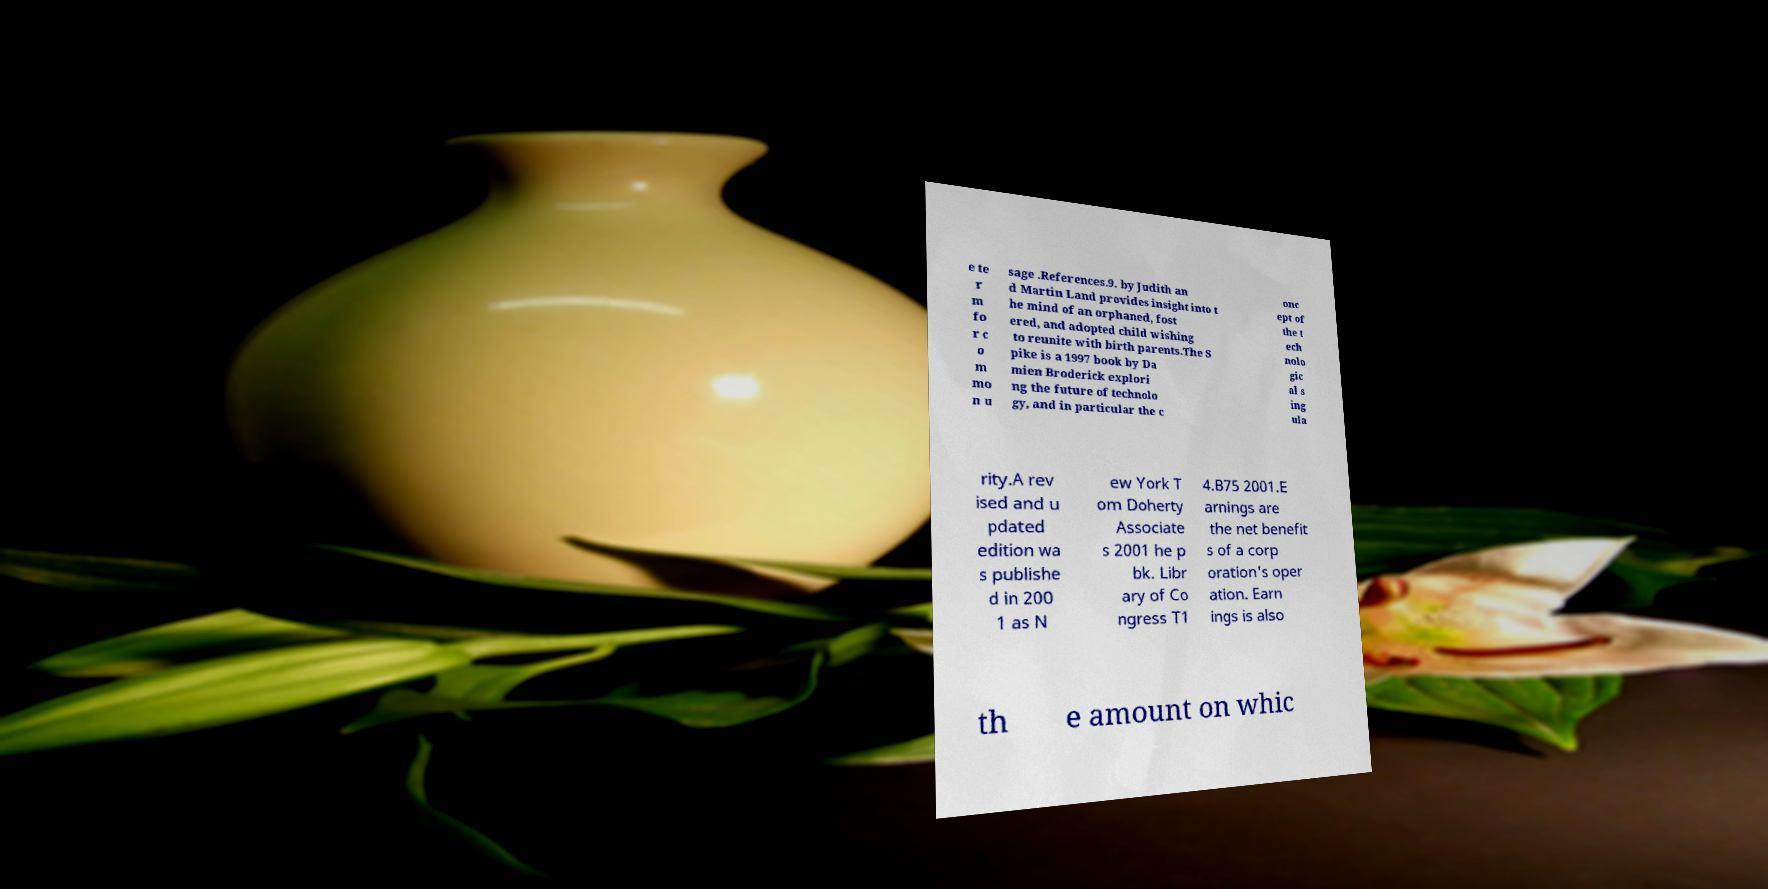For documentation purposes, I need the text within this image transcribed. Could you provide that? e te r m fo r c o m mo n u sage .References.9. by Judith an d Martin Land provides insight into t he mind of an orphaned, fost ered, and adopted child wishing to reunite with birth parents.The S pike is a 1997 book by Da mien Broderick explori ng the future of technolo gy, and in particular the c onc ept of the t ech nolo gic al s ing ula rity.A rev ised and u pdated edition wa s publishe d in 200 1 as N ew York T om Doherty Associate s 2001 he p bk. Libr ary of Co ngress T1 4.B75 2001.E arnings are the net benefit s of a corp oration's oper ation. Earn ings is also th e amount on whic 